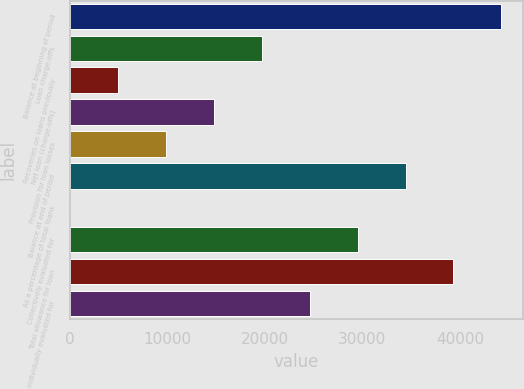Convert chart. <chart><loc_0><loc_0><loc_500><loc_500><bar_chart><fcel>Balance at beginning of period<fcel>Loan charge-offs<fcel>Recoveries on loans previously<fcel>Net loan (charge-offs)<fcel>Provision for loan losses<fcel>Balance at end of period<fcel>As a percentage of total loans<fcel>Collectively evaluated for<fcel>Total allowance for loan<fcel>Individually evaluated for<nl><fcel>44255.9<fcel>19670.1<fcel>4918.61<fcel>14752.9<fcel>9835.76<fcel>34421.6<fcel>1.45<fcel>29504.4<fcel>39338.7<fcel>24587.2<nl></chart> 